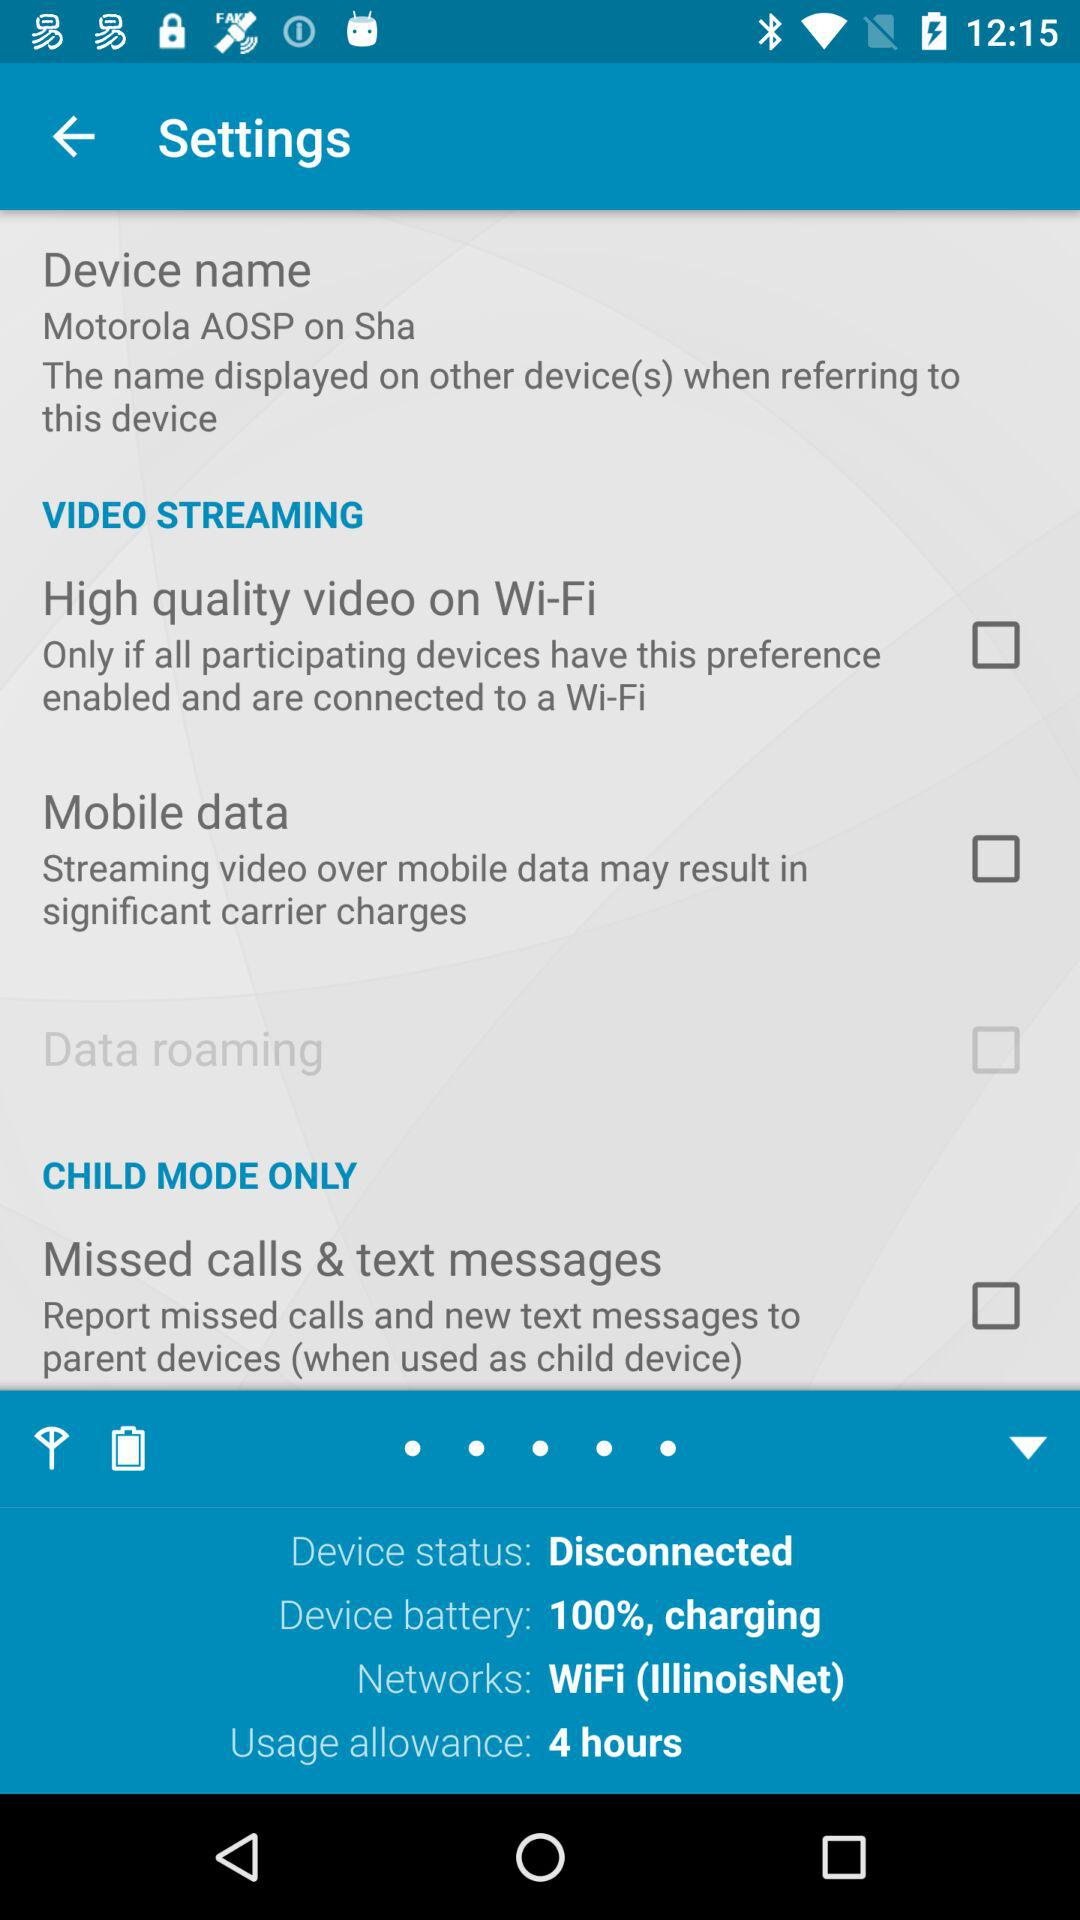What is the current status of the "Mobile data" under the "VIDEO STREAMING" setting? The current status of the "Mobile data" is "off". 